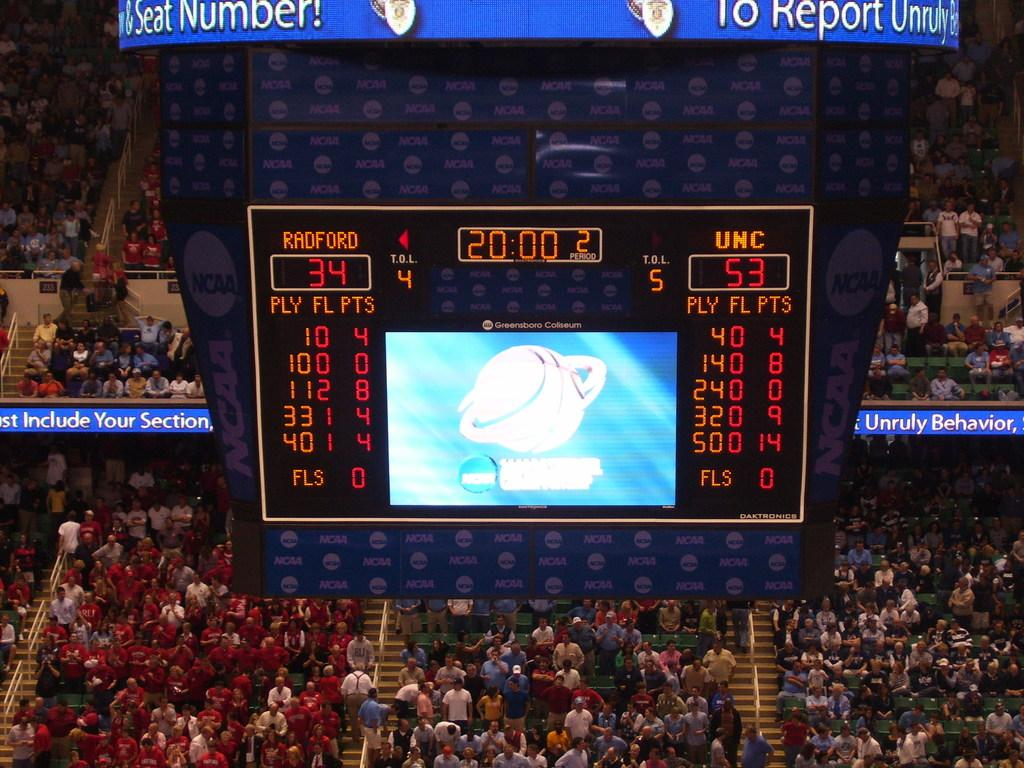<image>
Share a concise interpretation of the image provided. A scoreboard reveals that the game is at the 20:00 mark at 34 to 53. 